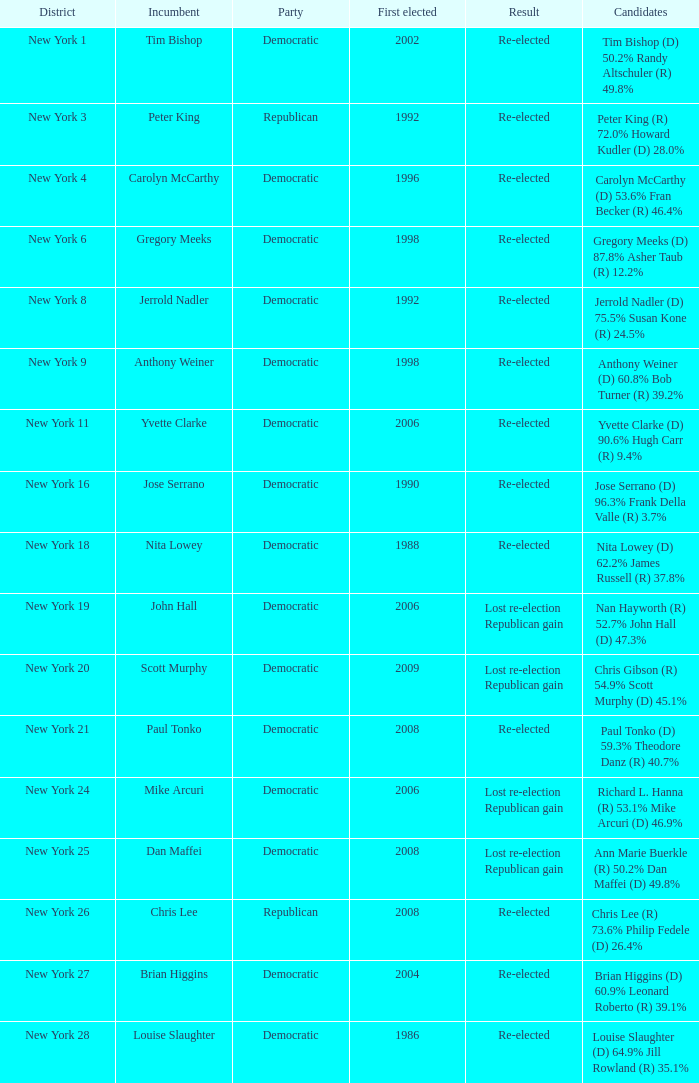Identify the individual who was first elected or re-elected with brian higgins. 2004.0. 